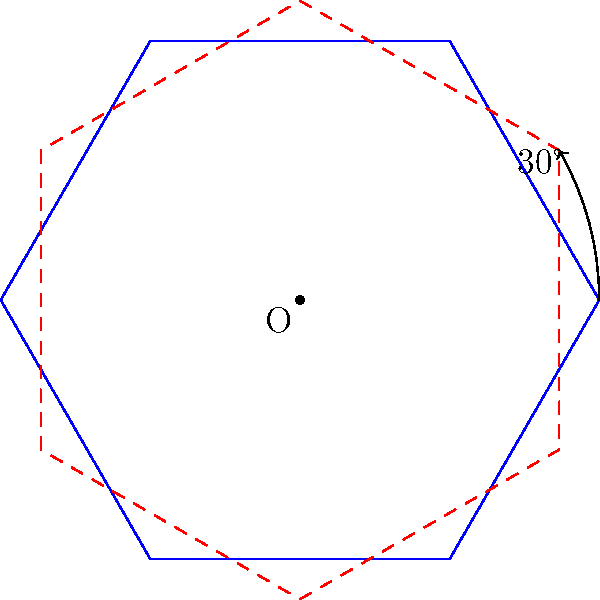A Star of David is rotated 30° clockwise around its center point O. How many vertices of the original star (blue) coincide with vertices of the rotated star (red dashed)? Let's approach this step-by-step:

1) The Star of David has 6 vertices, equally spaced around the center.

2) The angle between each vertex is 360° ÷ 6 = 60°.

3) When we rotate the star by 30°, we're rotating it by half the angle between two vertices.

4) This means that each vertex of the original star will land halfway between two vertices of the rotated star.

5) Since no vertex lands directly on another vertex, none of the vertices of the original star will coincide with vertices of the rotated star.

6) We can verify this by looking at the diagram. The blue (original) and red (rotated) stars do not intersect at any of their vertices.

Therefore, 0 vertices of the original star coincide with vertices of the rotated star.
Answer: 0 vertices 